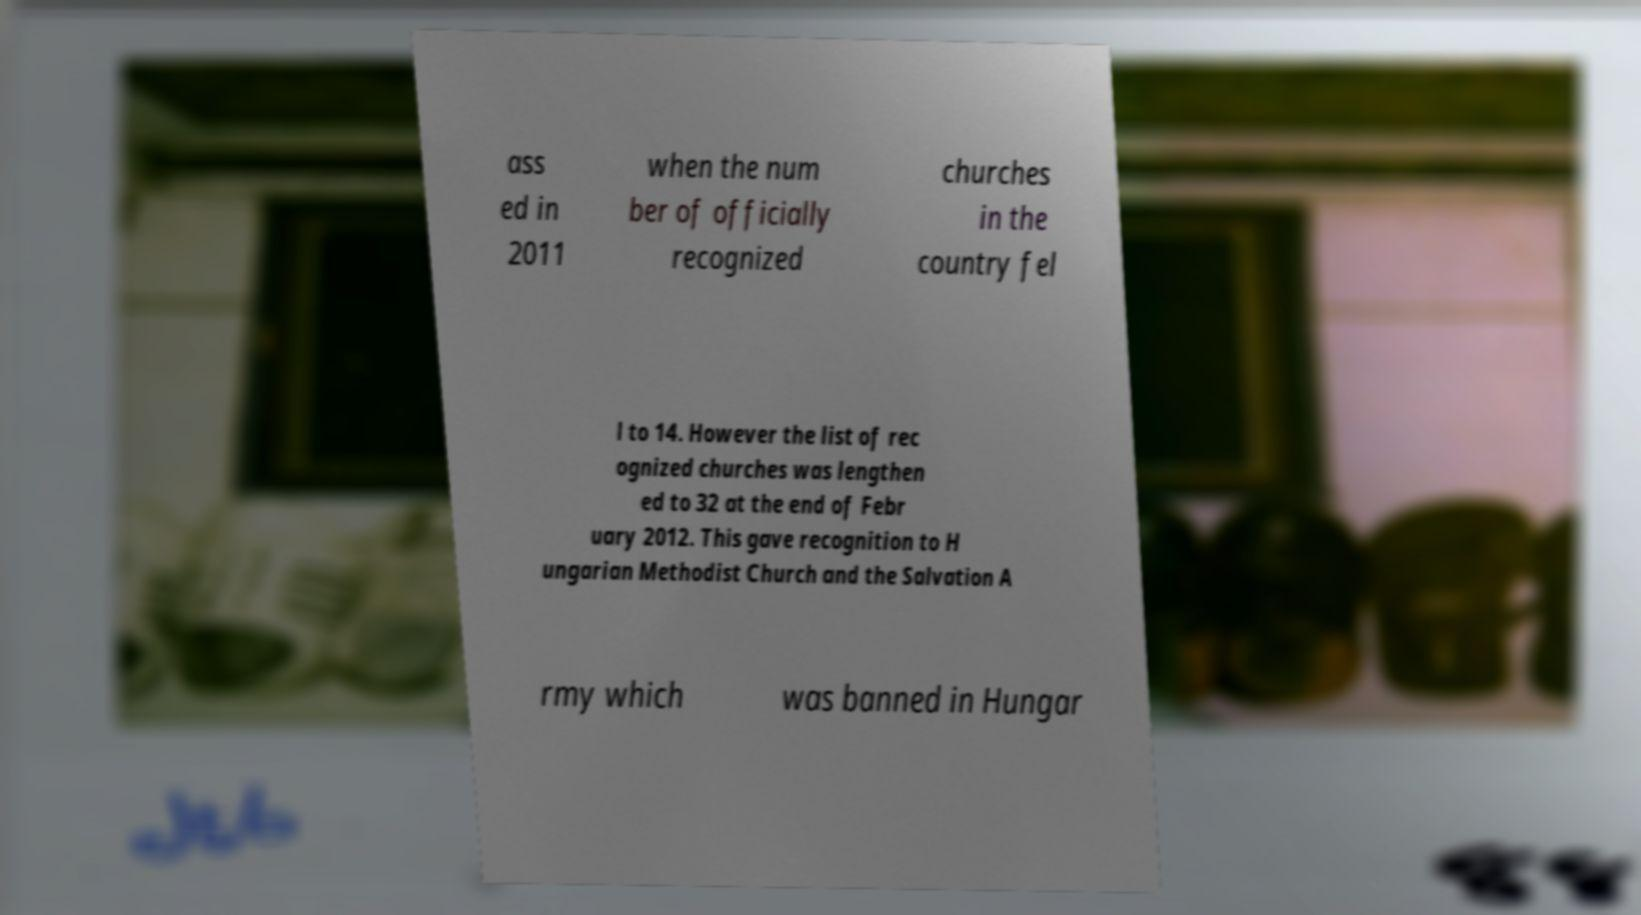There's text embedded in this image that I need extracted. Can you transcribe it verbatim? ass ed in 2011 when the num ber of officially recognized churches in the country fel l to 14. However the list of rec ognized churches was lengthen ed to 32 at the end of Febr uary 2012. This gave recognition to H ungarian Methodist Church and the Salvation A rmy which was banned in Hungar 